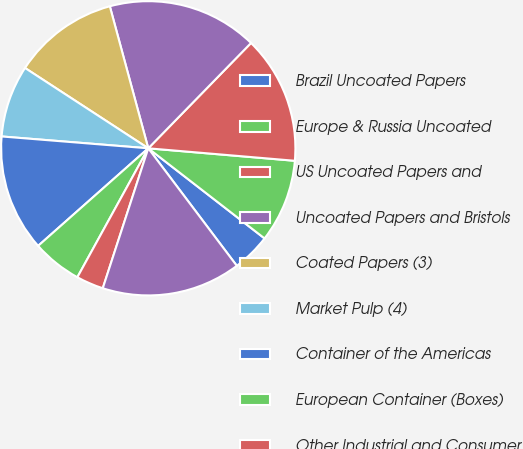Convert chart to OTSL. <chart><loc_0><loc_0><loc_500><loc_500><pie_chart><fcel>Brazil Uncoated Papers<fcel>Europe & Russia Uncoated<fcel>US Uncoated Papers and<fcel>Uncoated Papers and Bristols<fcel>Coated Papers (3)<fcel>Market Pulp (4)<fcel>Container of the Americas<fcel>European Container (Boxes)<fcel>Other Industrial and Consumer<fcel>Industrial and Consumer<nl><fcel>4.23%<fcel>9.14%<fcel>14.05%<fcel>16.51%<fcel>11.6%<fcel>7.91%<fcel>12.82%<fcel>5.46%<fcel>3.0%<fcel>15.28%<nl></chart> 